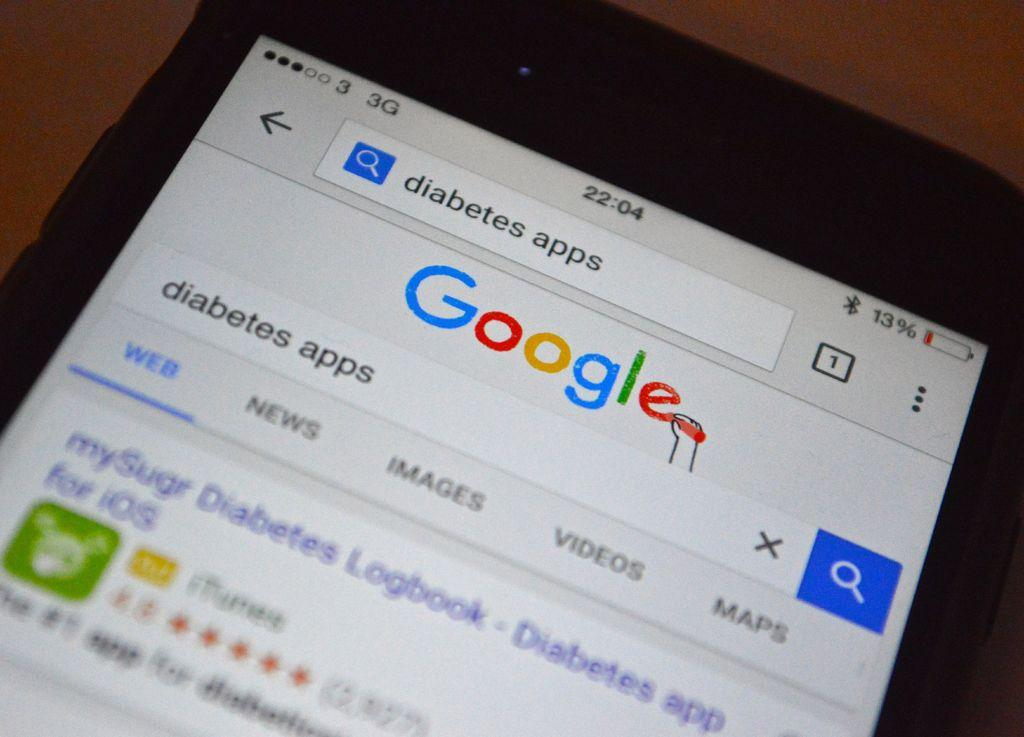What is the main object in the image? There is a display screen in the image. Can you describe the display screen in more detail? Unfortunately, the provided facts do not offer any additional details about the display screen. How many spiders are crawling on the display screen in the image? There are no spiders present in the image; it only features a display screen. What shape is the display screen in the image? The provided facts do not offer any information about the shape of the display screen. 